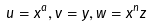<formula> <loc_0><loc_0><loc_500><loc_500>u = x ^ { a } , v = y , w = x ^ { n } z</formula> 